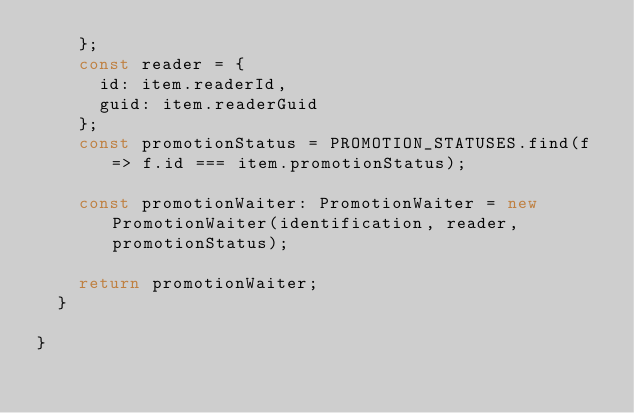Convert code to text. <code><loc_0><loc_0><loc_500><loc_500><_TypeScript_>    };
    const reader = {
      id: item.readerId,
      guid: item.readerGuid
    };
    const promotionStatus = PROMOTION_STATUSES.find(f => f.id === item.promotionStatus);

    const promotionWaiter: PromotionWaiter = new PromotionWaiter(identification, reader, promotionStatus);

    return promotionWaiter;
  }

}
</code> 